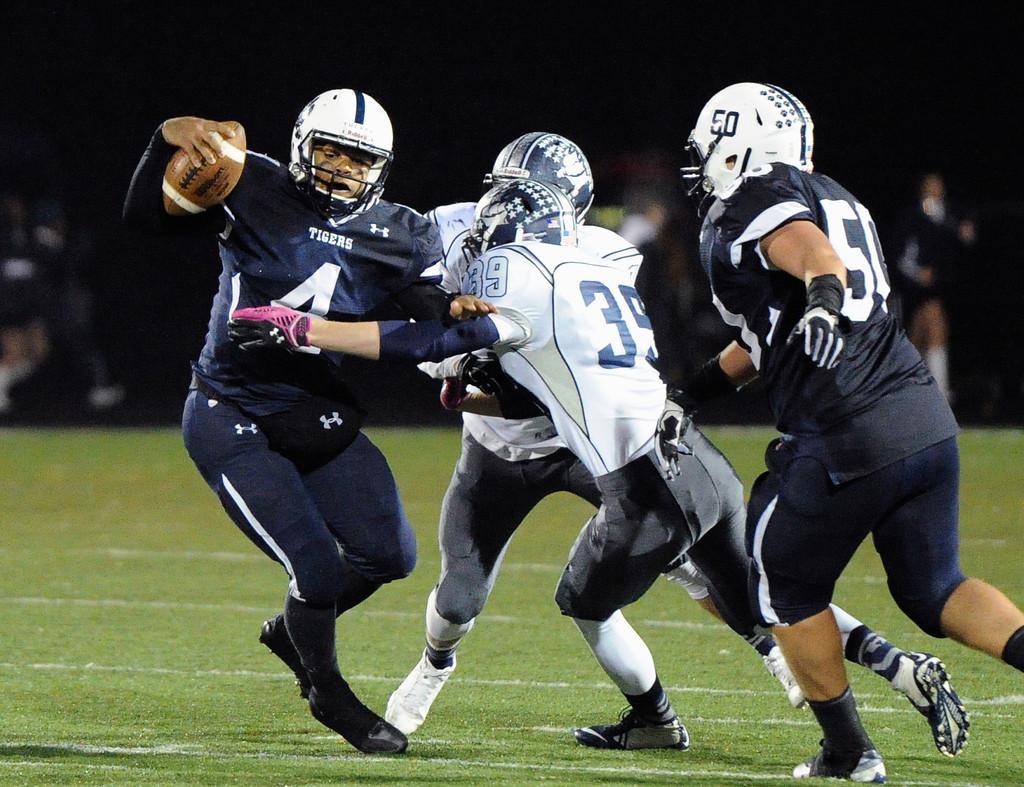In one or two sentences, can you explain what this image depicts? There are four persons wearing helmets. Two of them are in black color t-shirts and two of them are in white color t-shirts, playing on the grass in the ground. In the background, there are persons. 